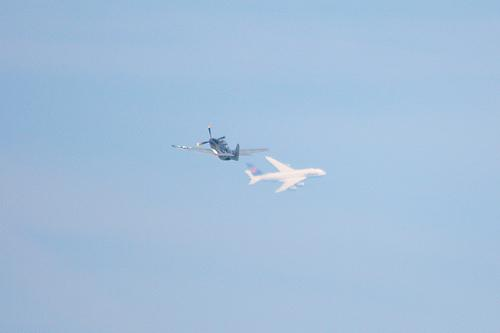Question: what is in the sky?
Choices:
A. Stars.
B. Clouds.
C. Kites.
D. Planes.
Answer with the letter. Answer: D Question: how many planes are pictured?
Choices:
A. One.
B. Two.
C. Three.
D. Four.
Answer with the letter. Answer: B Question: who flies the plane?
Choices:
A. The children who made them from paper.
B. The only person who survived the air pressure loss.
C. The people who constructed them and their remote controls.
D. Pilots.
Answer with the letter. Answer: D 